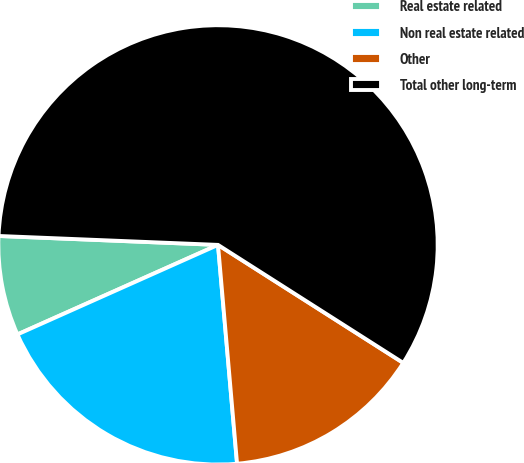Convert chart to OTSL. <chart><loc_0><loc_0><loc_500><loc_500><pie_chart><fcel>Real estate related<fcel>Non real estate related<fcel>Other<fcel>Total other long-term<nl><fcel>7.33%<fcel>19.7%<fcel>14.59%<fcel>58.38%<nl></chart> 